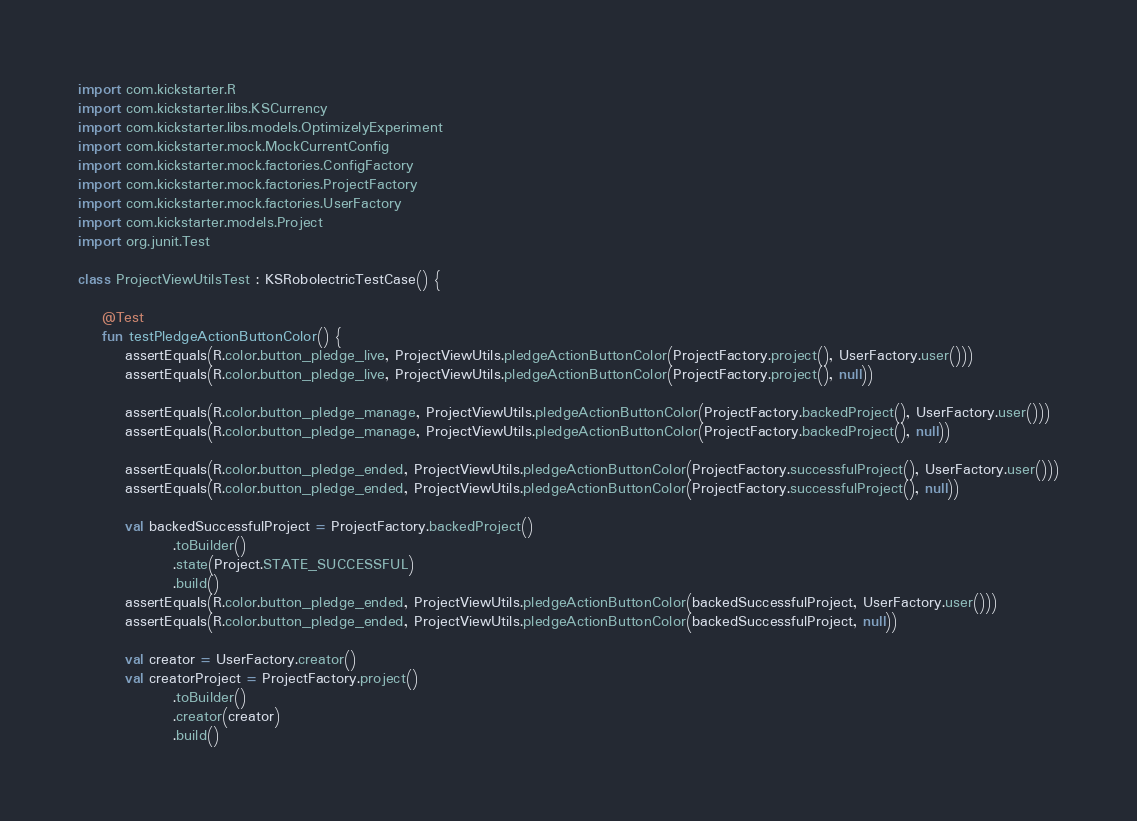Convert code to text. <code><loc_0><loc_0><loc_500><loc_500><_Kotlin_>import com.kickstarter.R
import com.kickstarter.libs.KSCurrency
import com.kickstarter.libs.models.OptimizelyExperiment
import com.kickstarter.mock.MockCurrentConfig
import com.kickstarter.mock.factories.ConfigFactory
import com.kickstarter.mock.factories.ProjectFactory
import com.kickstarter.mock.factories.UserFactory
import com.kickstarter.models.Project
import org.junit.Test

class ProjectViewUtilsTest : KSRobolectricTestCase() {

    @Test
    fun testPledgeActionButtonColor() {
        assertEquals(R.color.button_pledge_live, ProjectViewUtils.pledgeActionButtonColor(ProjectFactory.project(), UserFactory.user()))
        assertEquals(R.color.button_pledge_live, ProjectViewUtils.pledgeActionButtonColor(ProjectFactory.project(), null))

        assertEquals(R.color.button_pledge_manage, ProjectViewUtils.pledgeActionButtonColor(ProjectFactory.backedProject(), UserFactory.user()))
        assertEquals(R.color.button_pledge_manage, ProjectViewUtils.pledgeActionButtonColor(ProjectFactory.backedProject(), null))

        assertEquals(R.color.button_pledge_ended, ProjectViewUtils.pledgeActionButtonColor(ProjectFactory.successfulProject(), UserFactory.user()))
        assertEquals(R.color.button_pledge_ended, ProjectViewUtils.pledgeActionButtonColor(ProjectFactory.successfulProject(), null))

        val backedSuccessfulProject = ProjectFactory.backedProject()
                .toBuilder()
                .state(Project.STATE_SUCCESSFUL)
                .build()
        assertEquals(R.color.button_pledge_ended, ProjectViewUtils.pledgeActionButtonColor(backedSuccessfulProject, UserFactory.user()))
        assertEquals(R.color.button_pledge_ended, ProjectViewUtils.pledgeActionButtonColor(backedSuccessfulProject, null))

        val creator = UserFactory.creator()
        val creatorProject = ProjectFactory.project()
                .toBuilder()
                .creator(creator)
                .build()</code> 